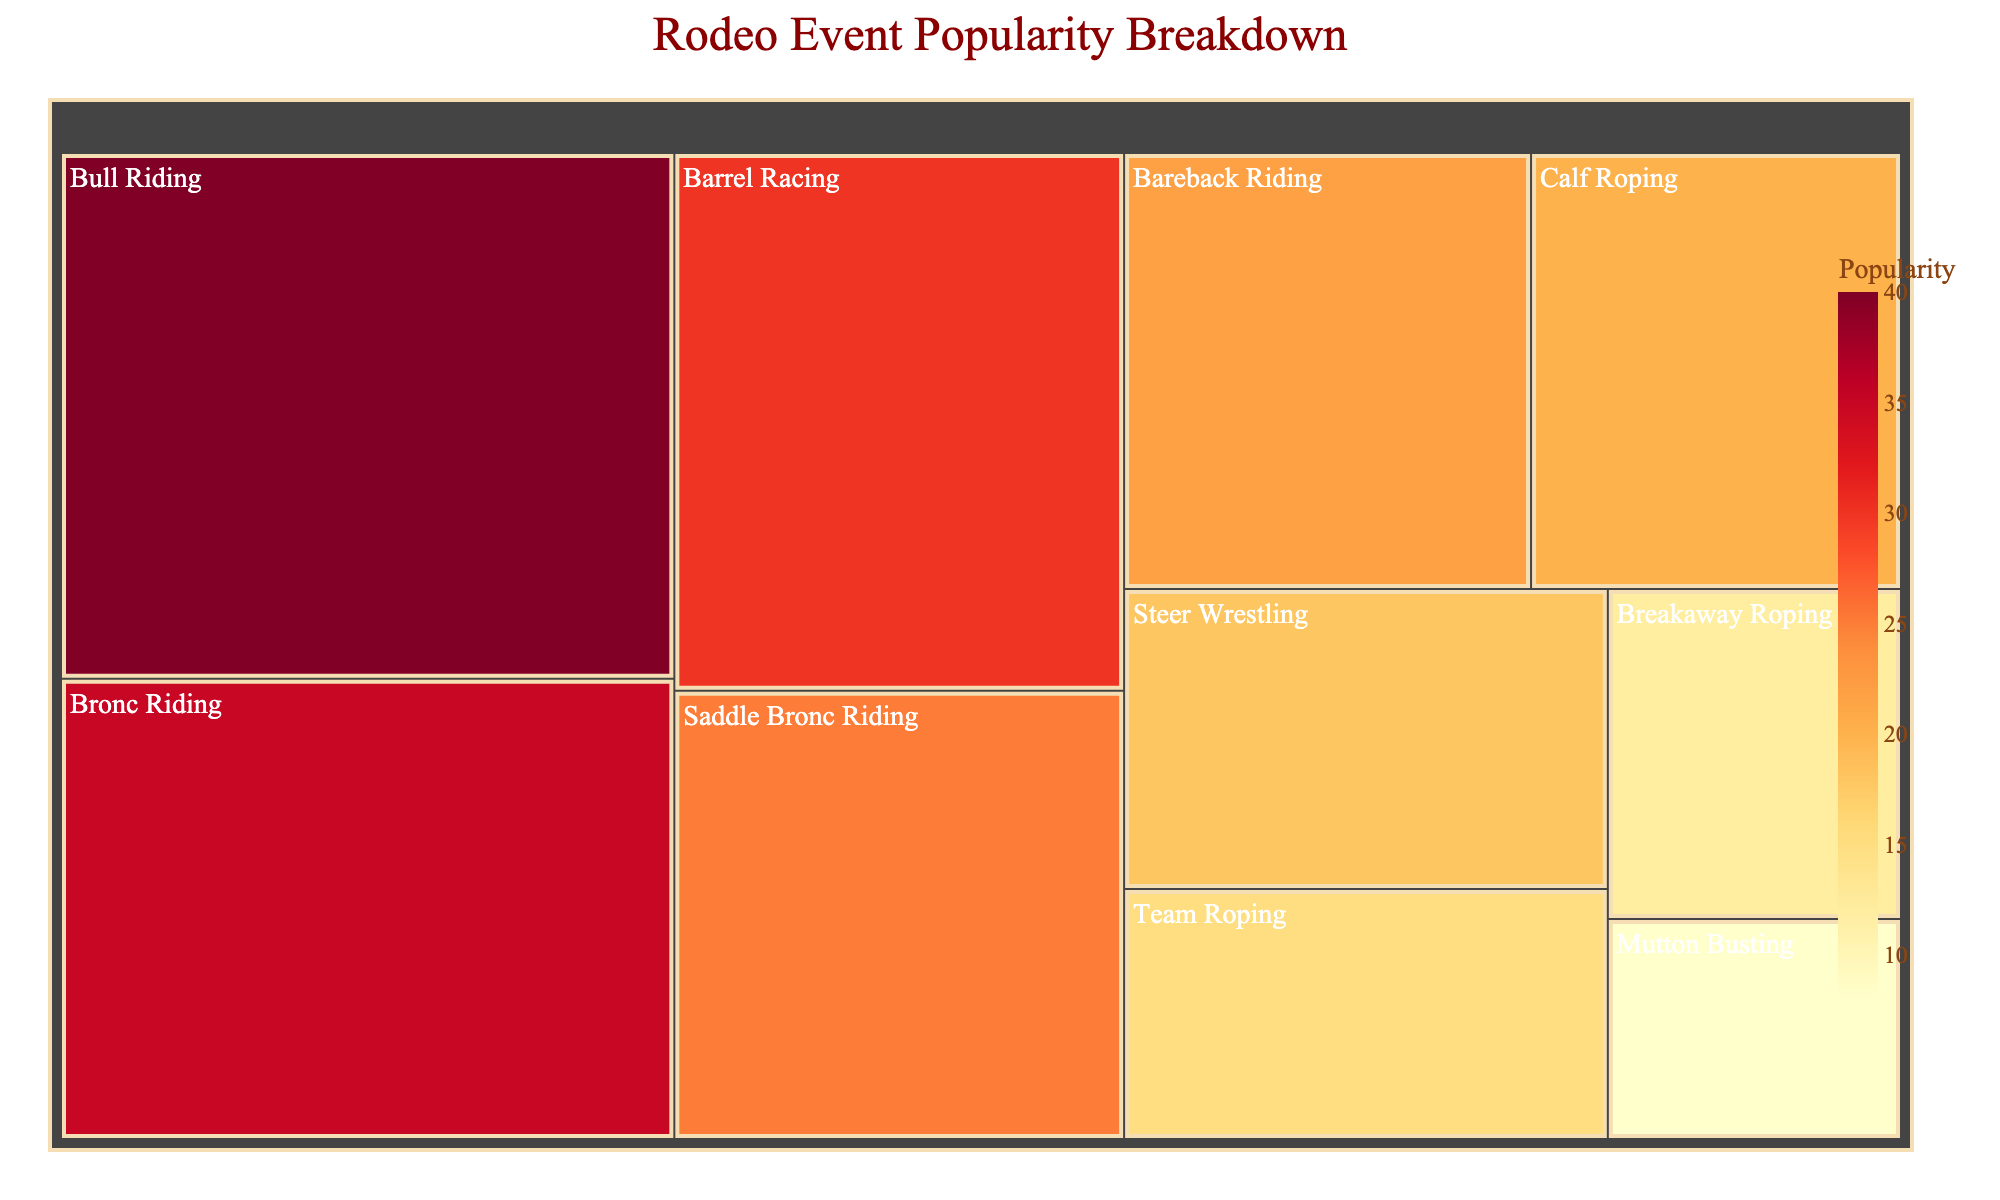How many events are shown in the treemap? Count each unique event block shown in the treemap.
Answer: 10 Which event is the most popular? Identify the event with the largest block in the treemap and the highest popularity value.
Answer: Bull Riding Which event is the least popular? Identify the event with the smallest block in the treemap and the lowest popularity value.
Answer: Mutton Busting How much more popular is Bronc Riding compared to Breakaway Roping? Subtract the popularity value of Breakaway Roping from the popularity value of Bronc Riding (35 - 12).
Answer: 23 What is the combined popularity of Team Roping, Calf Roping, and Steer Wrestling? Add the popularity values of Team Roping (15), Calf Roping (20), and Steer Wrestling (18) (15 + 20 + 18).
Answer: 53 Is Barrel Racing more popular than Saddle Bronc Riding? Compare the popularity values of Barrel Racing (30) and Saddle Bronc Riding (25).
Answer: Yes Which is more popular, Bareback Riding or Breakaway Roping? Compare the popularity values of Bareback Riding (22) and Breakaway Roping (12).
Answer: Bareback Riding What is the overall popularity of the top three events? Identify the top three events by their popularity values and then sum these values (Bull Riding 40, Bronc Riding 35, Barrel Racing 30) (40 + 35 + 30).
Answer: 105 What event has a popularity closest to 20? Identify the event with popularity value closest to 20 (Calf Roping with popularity 20).
Answer: Calf Roping Which is the least popular event among those with a popularity value greater than 20? Identify events with popularity values greater than 20, then find the smallest value among them (Saddle Bronc Riding 25, Bareback Riding 22).
Answer: Bareback Riding 